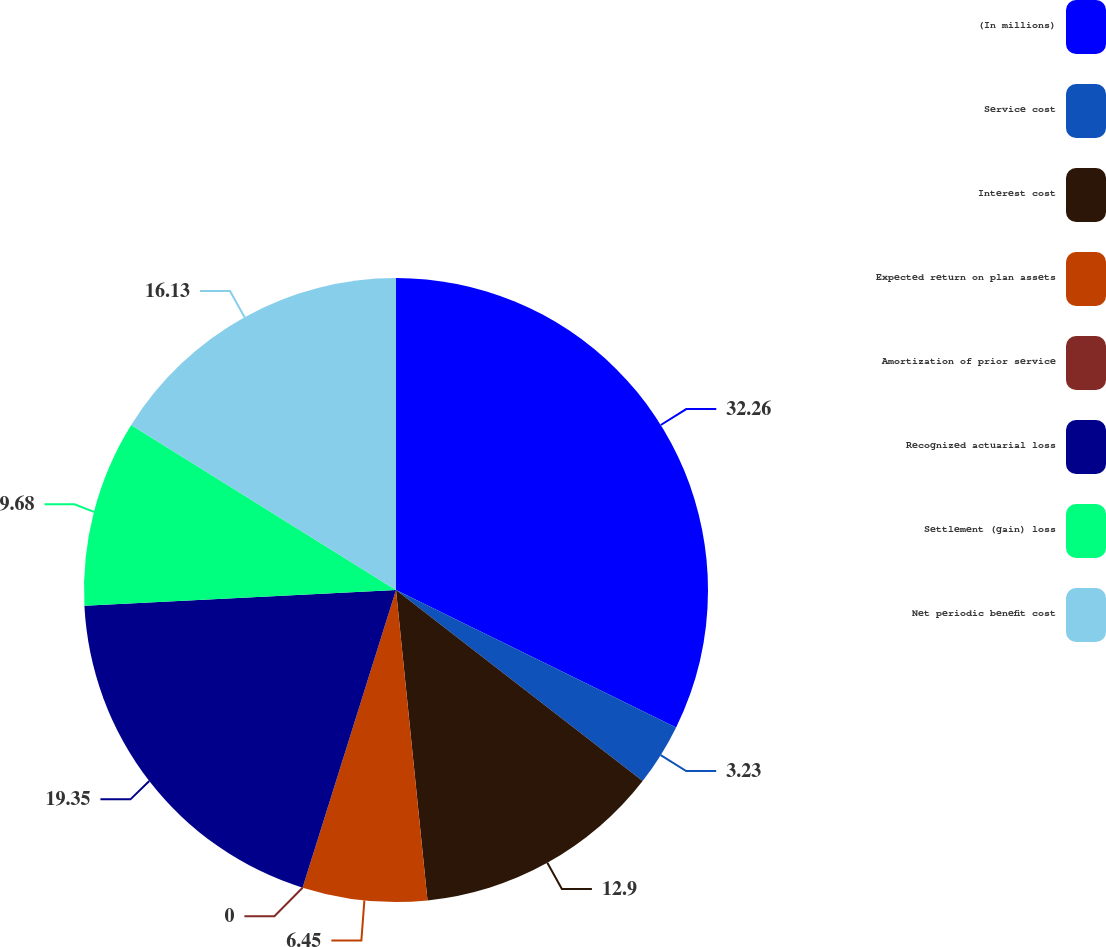<chart> <loc_0><loc_0><loc_500><loc_500><pie_chart><fcel>(In millions)<fcel>Service cost<fcel>Interest cost<fcel>Expected return on plan assets<fcel>Amortization of prior service<fcel>Recognized actuarial loss<fcel>Settlement (gain) loss<fcel>Net periodic benefit cost<nl><fcel>32.26%<fcel>3.23%<fcel>12.9%<fcel>6.45%<fcel>0.0%<fcel>19.35%<fcel>9.68%<fcel>16.13%<nl></chart> 